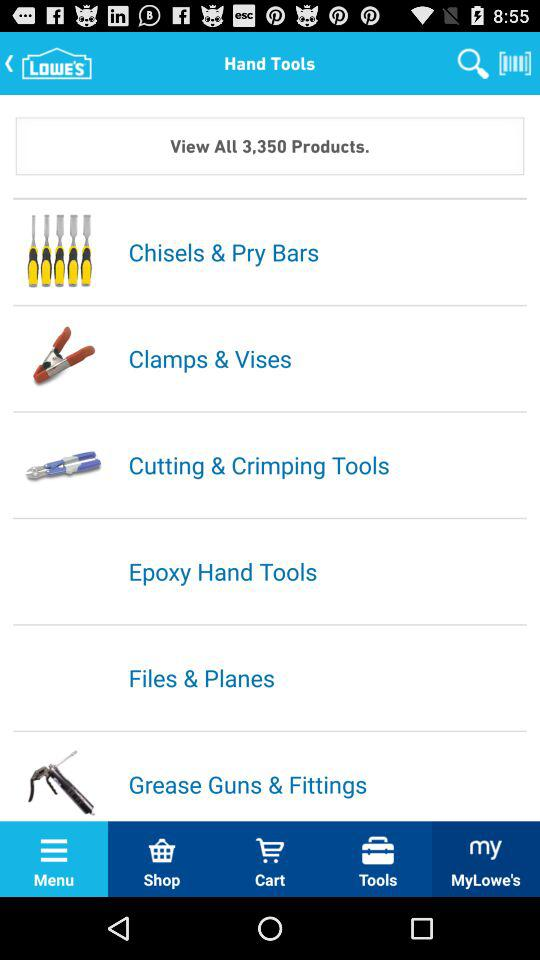What is the name of the application? The name of the application is "Lowe's". 